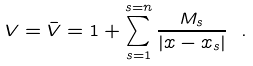<formula> <loc_0><loc_0><loc_500><loc_500>V = \bar { V } = 1 + \sum _ { s = 1 } ^ { s = n } \frac { M _ { s } } { | { x } - { x } _ { s } | } \ .</formula> 